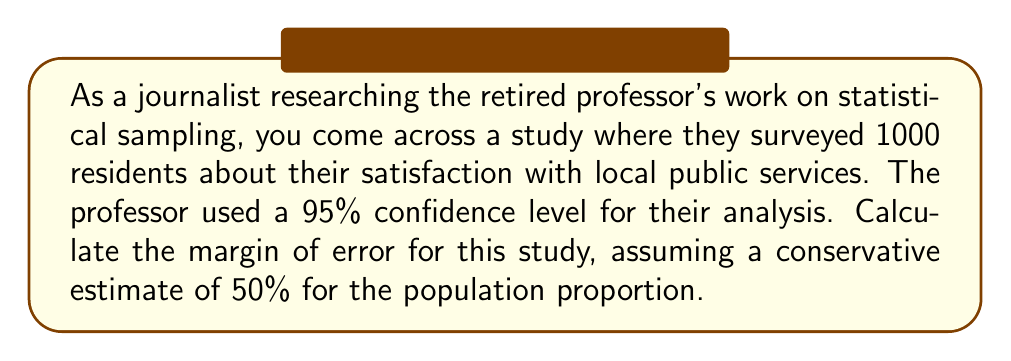Could you help me with this problem? To calculate the margin of error, we'll follow these steps:

1. Identify the given information:
   - Sample size (n) = 1000
   - Confidence level = 95%
   - Estimated population proportion (p) = 0.5 (50%)

2. Find the z-score for a 95% confidence level:
   The z-score for a 95% confidence level is 1.96.

3. Use the margin of error formula:
   $$\text{Margin of Error} = z \sqrt{\frac{p(1-p)}{n}}$$

   Where:
   z = z-score for the confidence level
   p = estimated population proportion
   n = sample size

4. Substitute the values into the formula:
   $$\text{Margin of Error} = 1.96 \sqrt{\frac{0.5(1-0.5)}{1000}}$$

5. Simplify:
   $$\text{Margin of Error} = 1.96 \sqrt{\frac{0.25}{1000}}$$
   $$\text{Margin of Error} = 1.96 \sqrt{0.00025}$$
   $$\text{Margin of Error} = 1.96 \times 0.01581139$$
   $$\text{Margin of Error} = 0.03099$$

6. Convert to percentage:
   $$\text{Margin of Error} = 3.099\%$$

7. Round to three decimal places:
   $$\text{Margin of Error} = 3.100\%$$
Answer: 3.100% 